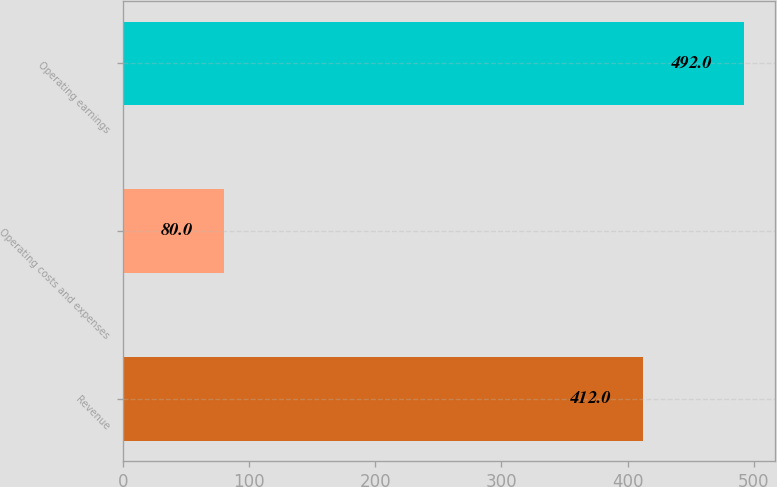Convert chart. <chart><loc_0><loc_0><loc_500><loc_500><bar_chart><fcel>Revenue<fcel>Operating costs and expenses<fcel>Operating earnings<nl><fcel>412<fcel>80<fcel>492<nl></chart> 